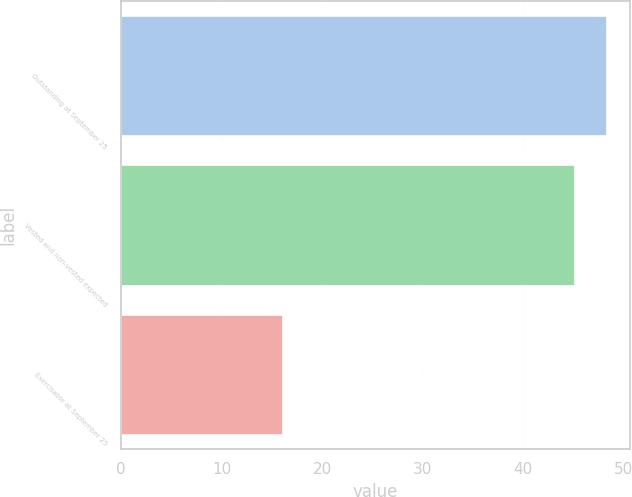<chart> <loc_0><loc_0><loc_500><loc_500><bar_chart><fcel>Outstanding at September 25<fcel>Vested and non-vested expected<fcel>Exercisable at September 25<nl><fcel>48.2<fcel>45<fcel>16<nl></chart> 